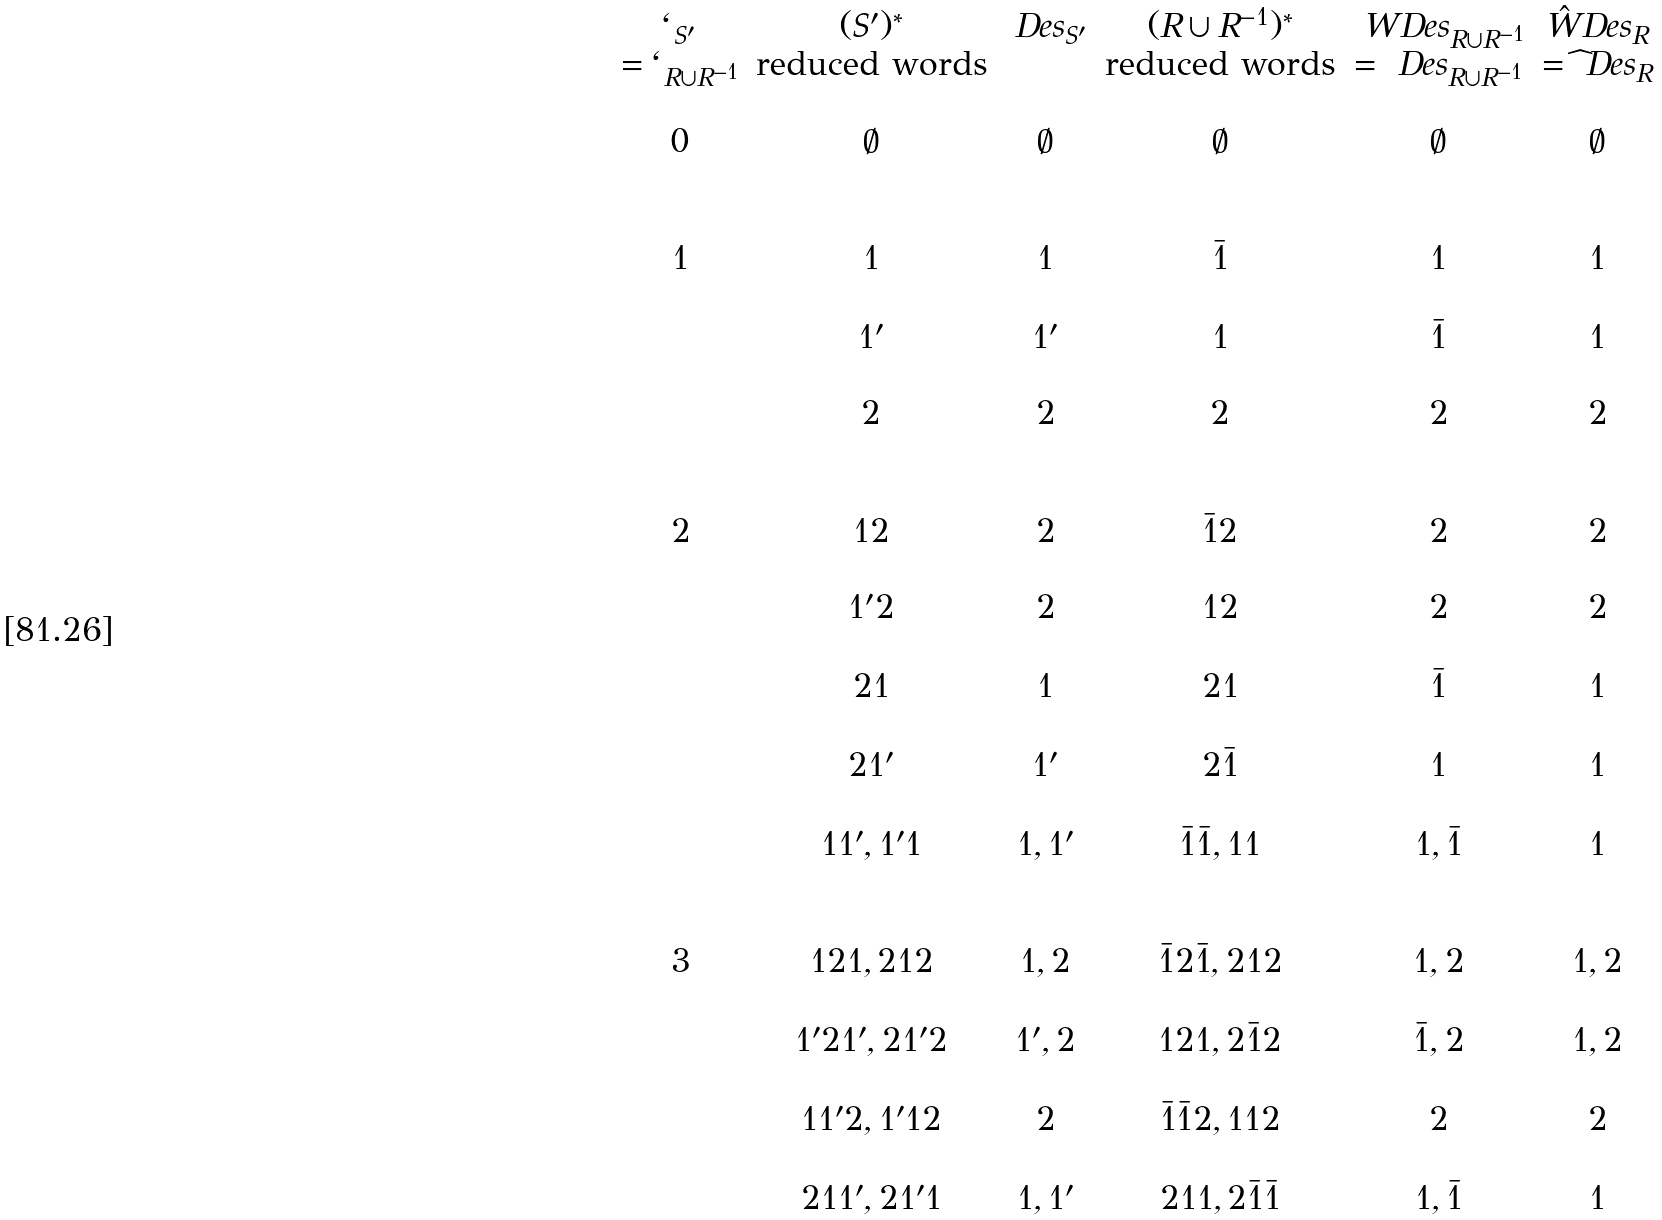Convert formula to latex. <formula><loc_0><loc_0><loc_500><loc_500>\begin{matrix} \ell _ { S ^ { \prime } } & ( S ^ { \prime } ) ^ { * } & \ D e s _ { S ^ { \prime } } & ( R \cup R ^ { - 1 } ) ^ { * } & \ W D e s _ { R \cup R ^ { - 1 } } & \hat { W } D e s _ { R } \\ = \ell _ { R \cup R ^ { - 1 } } & \text {reduced words} & & \text {reduced words} & = \ D e s _ { R \cup R ^ { - 1 } } & = \widehat { \ } D e s _ { R } \\ & & & & \\ 0 & \emptyset & \emptyset & \emptyset & \emptyset & \emptyset \\ & & & & \\ & & & & \\ 1 & 1 & 1 & \bar { 1 } & 1 & 1 \\ & & & & \\ & 1 ^ { \prime } & 1 ^ { \prime } & 1 & \bar { 1 } & 1 \\ & & & & \\ & 2 & 2 & 2 & 2 & 2 \\ & & & & \\ & & & & \\ 2 & 1 2 & 2 & \bar { 1 } 2 & 2 & 2 \\ & & & & \\ & 1 ^ { \prime } 2 & 2 & 1 2 & 2 & 2 \\ & & & & \\ & 2 1 & 1 & 2 1 & \bar { 1 } & 1 \\ & & & & \\ & 2 1 ^ { \prime } & 1 ^ { \prime } & 2 \bar { 1 } & 1 & 1 \\ & & & & \\ & 1 1 ^ { \prime } , 1 ^ { \prime } 1 & 1 , 1 ^ { \prime } & \bar { 1 } \bar { 1 } , 1 1 & 1 , \bar { 1 } & 1 \\ & & & & \\ & & & & \\ 3 & 1 2 1 , 2 1 2 & 1 , 2 & \bar { 1 } 2 \bar { 1 } , 2 1 2 & 1 , 2 & 1 , 2 \\ & & & & \\ & 1 ^ { \prime } 2 1 ^ { \prime } , 2 1 ^ { \prime } 2 & 1 ^ { \prime } , 2 & 1 2 1 , 2 \bar { 1 } 2 & \bar { 1 } , 2 & 1 , 2 \\ & & & & \\ & 1 1 ^ { \prime } 2 , 1 ^ { \prime } 1 2 & 2 & \bar { 1 } \bar { 1 } 2 , 1 1 2 & 2 & 2 \\ & & & & \\ & 2 1 1 ^ { \prime } , 2 1 ^ { \prime } 1 & 1 , 1 ^ { \prime } & 2 1 1 , 2 \bar { 1 } \bar { 1 } & 1 , \bar { 1 } & 1 \\ & & & & \\ \end{matrix}</formula> 